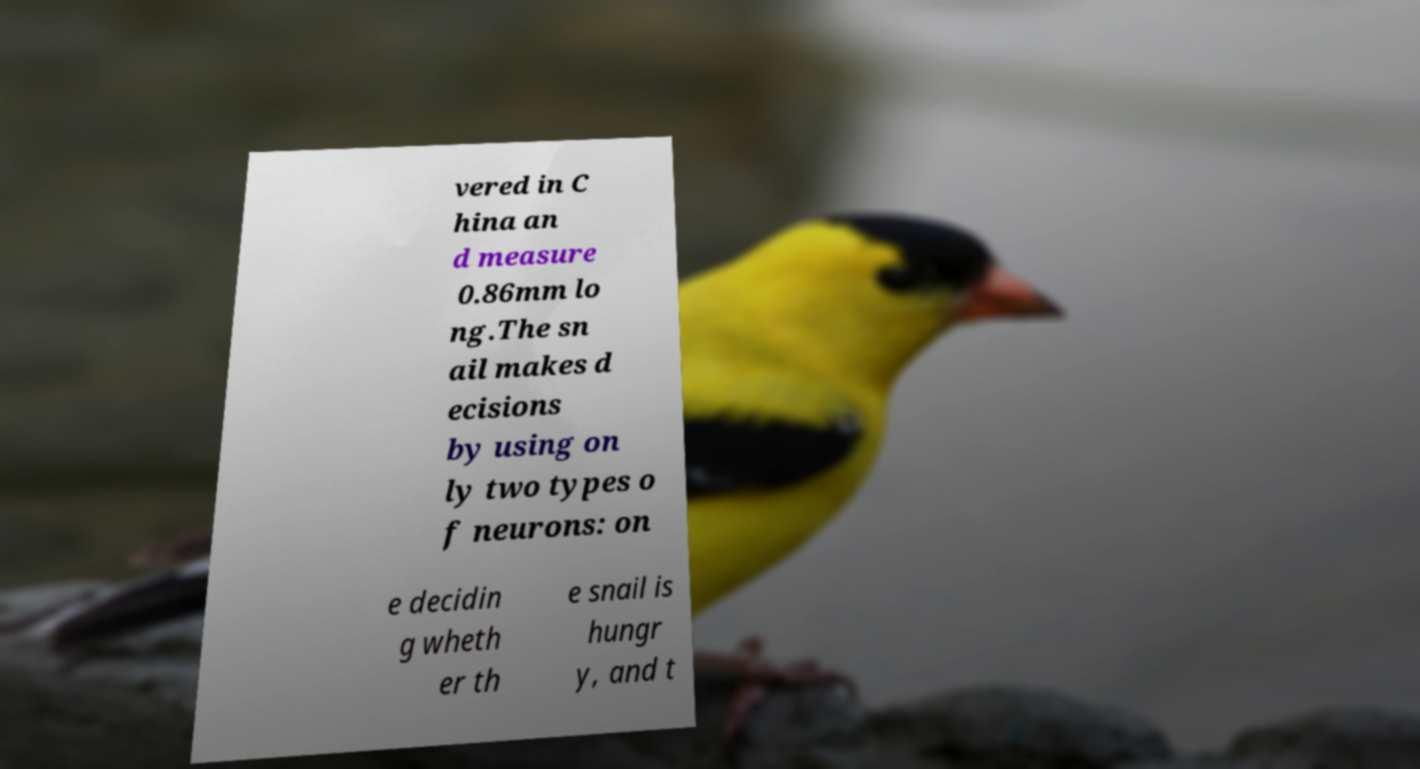What messages or text are displayed in this image? I need them in a readable, typed format. vered in C hina an d measure 0.86mm lo ng.The sn ail makes d ecisions by using on ly two types o f neurons: on e decidin g wheth er th e snail is hungr y, and t 